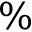<formula> <loc_0><loc_0><loc_500><loc_500>\%</formula> 